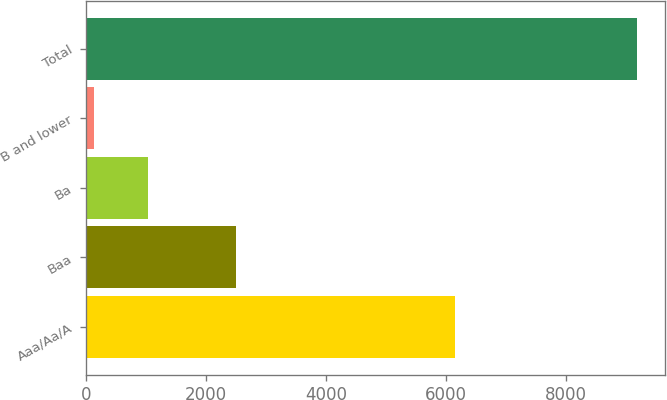<chart> <loc_0><loc_0><loc_500><loc_500><bar_chart><fcel>Aaa/Aa/A<fcel>Baa<fcel>Ba<fcel>B and lower<fcel>Total<nl><fcel>6142<fcel>2493<fcel>1032.1<fcel>127<fcel>9178<nl></chart> 